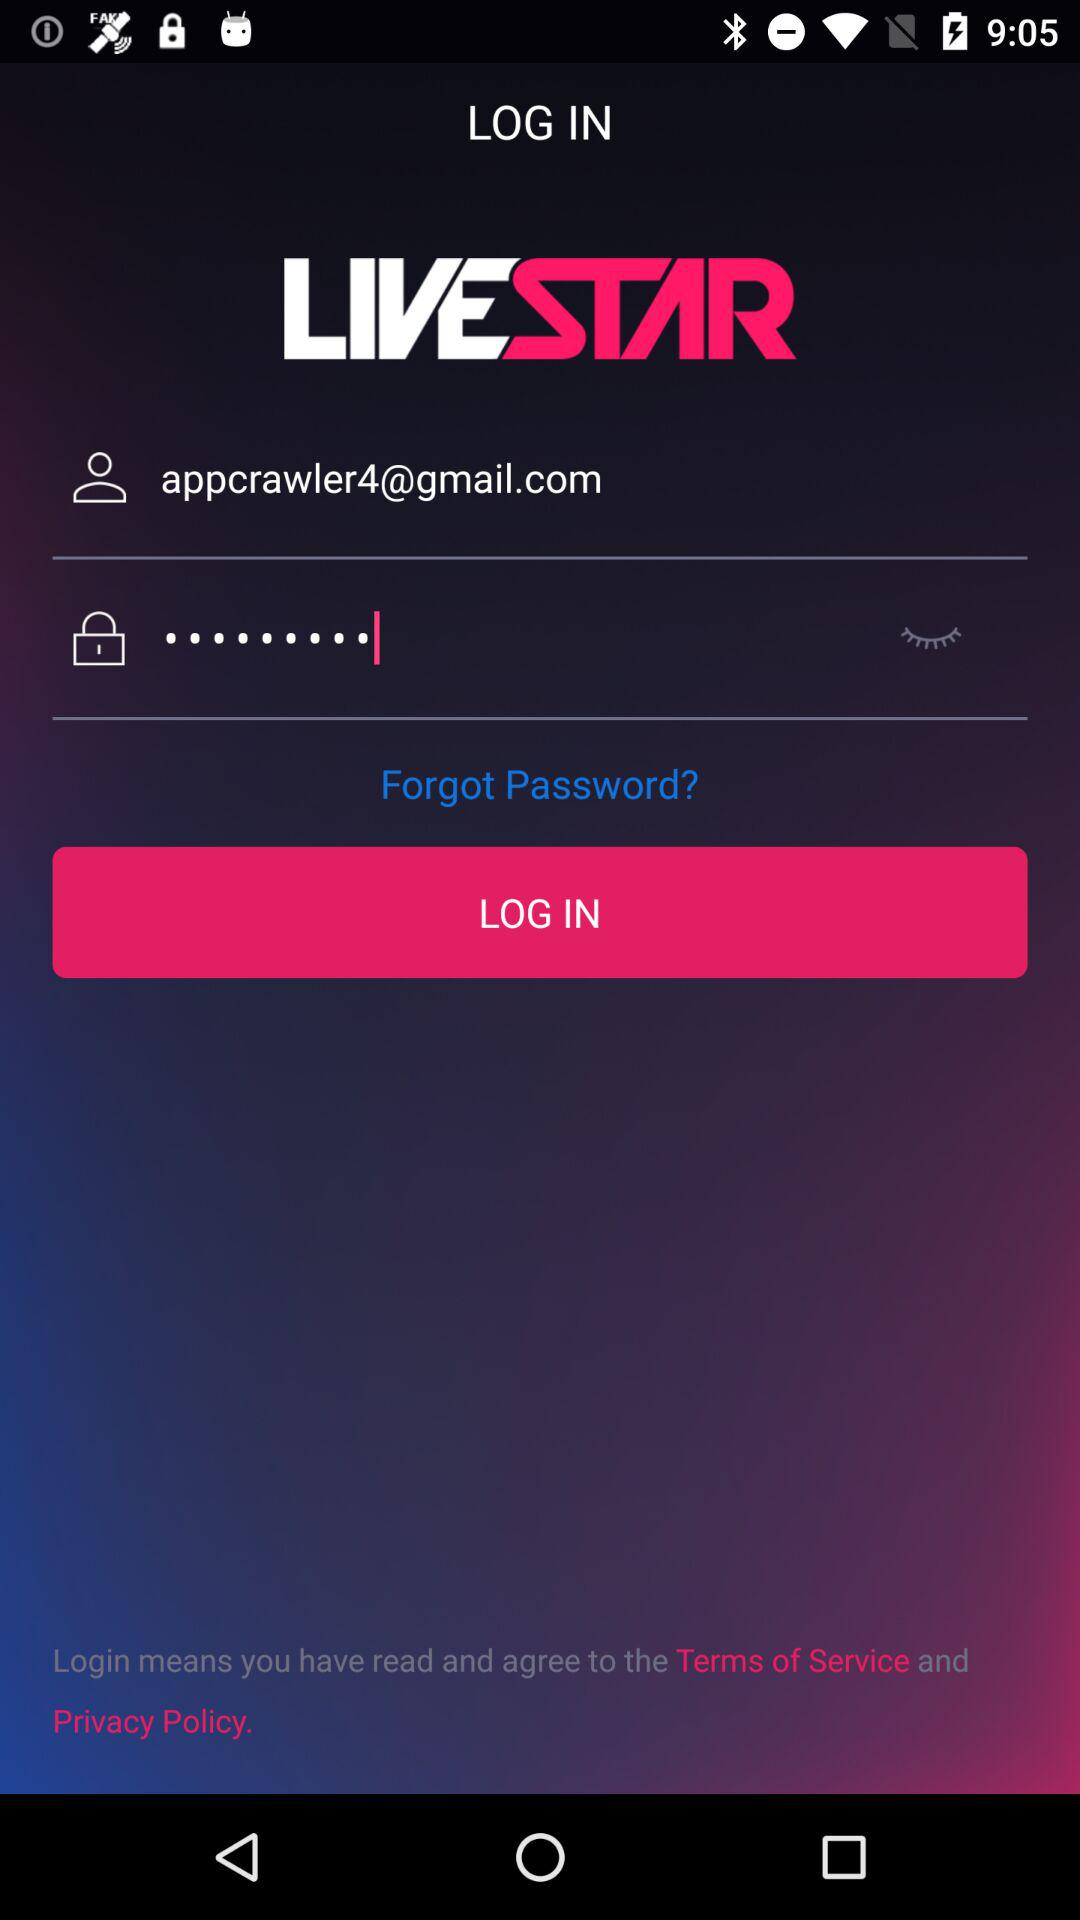What's the Gmail address? The Gmail address is appcrawler4@gmail.com. 